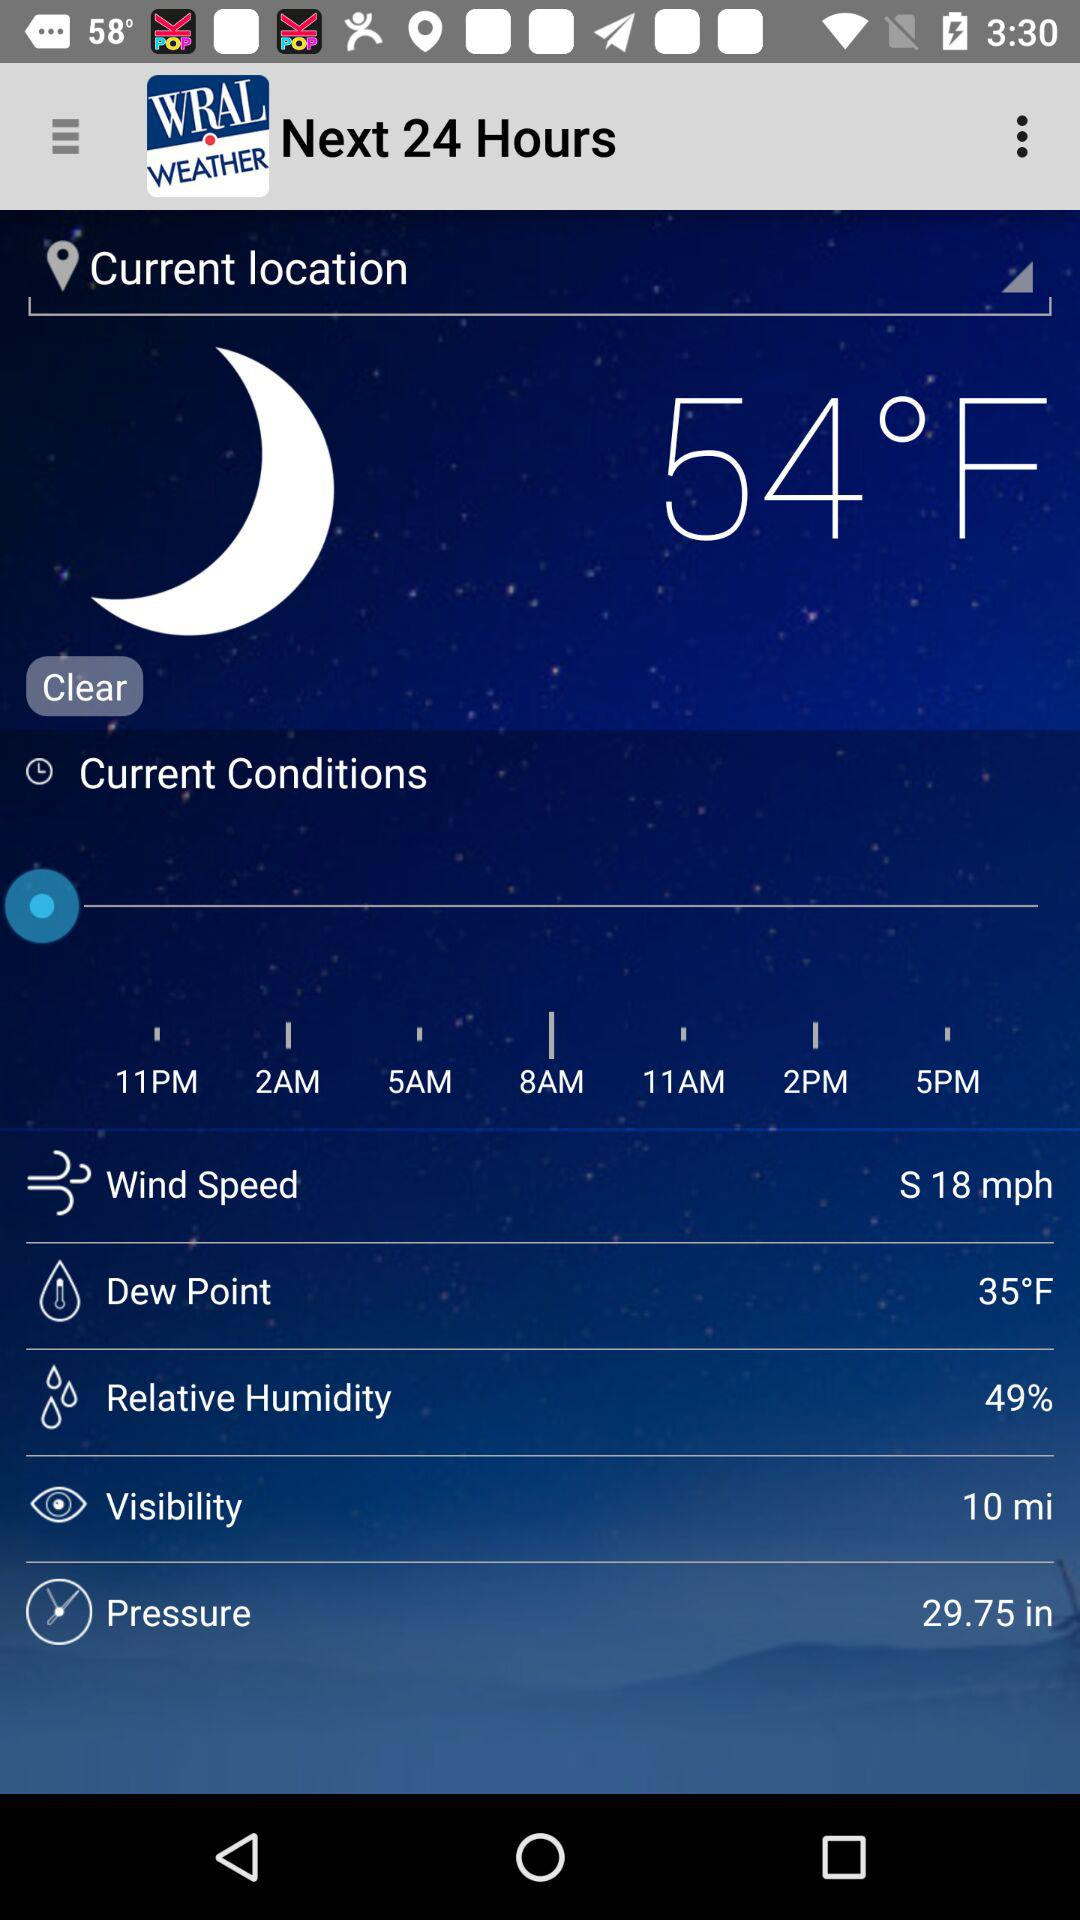Which is the unit of wind speed? The unit of wind speed is mph. 